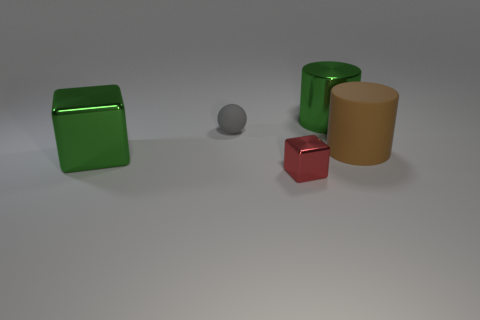Add 1 big cylinders. How many objects exist? 6 Add 4 tiny red objects. How many tiny red objects are left? 5 Add 2 big metal objects. How many big metal objects exist? 4 Subtract 1 red blocks. How many objects are left? 4 Subtract all cylinders. How many objects are left? 3 Subtract all yellow cubes. Subtract all blue balls. How many cubes are left? 2 Subtract all red balls. How many blue cylinders are left? 0 Subtract all big metal cylinders. Subtract all big rubber objects. How many objects are left? 3 